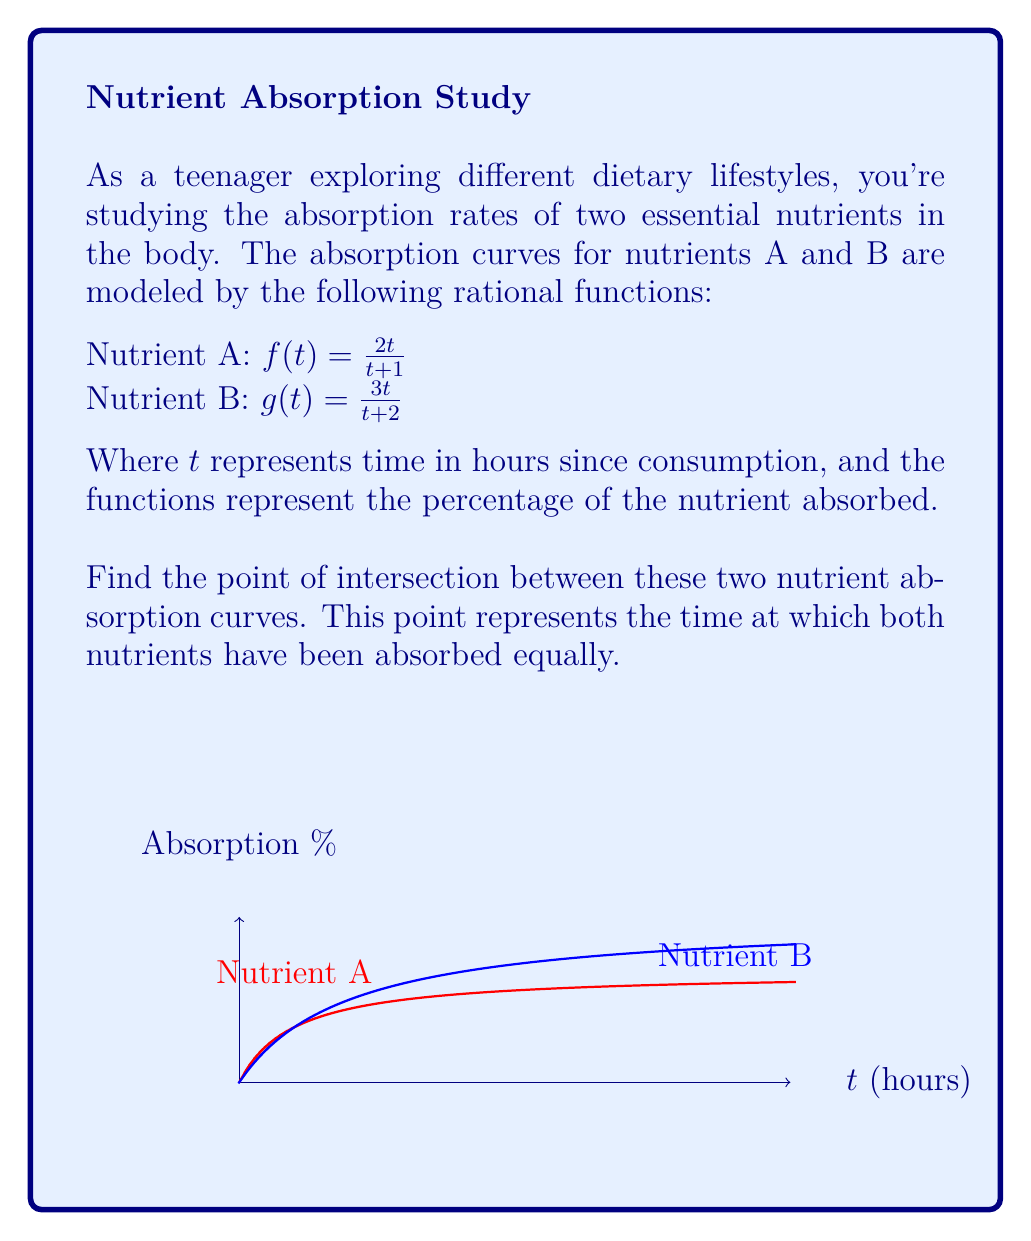Solve this math problem. Let's solve this step-by-step:

1) To find the point of intersection, we need to set the two functions equal to each other:

   $\frac{2t}{t+1} = \frac{3t}{t+2}$

2) To solve this equation, let's first cross-multiply:

   $2t(t+2) = 3t(t+1)$

3) Expand the brackets:

   $2t^2 + 4t = 3t^2 + 3t$

4) Subtract $2t^2$ from both sides:

   $4t = t^2 + 3t$

5) Subtract $3t$ from both sides:

   $t = t^2$

6) Subtract $t$ from both sides:

   $0 = t^2 - t$

7) Factor out $t$:

   $0 = t(t - 1)$

8) Set each factor to zero and solve:

   $t = 0$ or $t = 1$

9) $t = 0$ doesn't make sense in this context as it would mean no absorption. Therefore, $t = 1$ is our solution.

10) To find the y-coordinate of the intersection point, we can plug $t = 1$ into either of the original functions. Let's use $f(t)$:

    $f(1) = \frac{2(1)}{1+1} = \frac{2}{2} = 1$

Therefore, the point of intersection is $(1, 1)$, meaning after 1 hour, both nutrients have been absorbed equally at 100%.
Answer: (1, 1) 